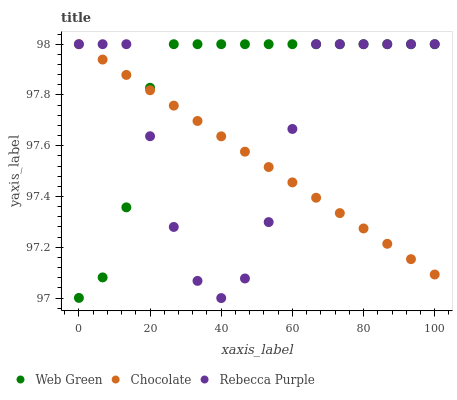Does Chocolate have the minimum area under the curve?
Answer yes or no. Yes. Does Web Green have the maximum area under the curve?
Answer yes or no. Yes. Does Web Green have the minimum area under the curve?
Answer yes or no. No. Does Chocolate have the maximum area under the curve?
Answer yes or no. No. Is Chocolate the smoothest?
Answer yes or no. Yes. Is Rebecca Purple the roughest?
Answer yes or no. Yes. Is Web Green the smoothest?
Answer yes or no. No. Is Web Green the roughest?
Answer yes or no. No. Does Rebecca Purple have the lowest value?
Answer yes or no. Yes. Does Web Green have the lowest value?
Answer yes or no. No. Does Chocolate have the highest value?
Answer yes or no. Yes. Does Chocolate intersect Rebecca Purple?
Answer yes or no. Yes. Is Chocolate less than Rebecca Purple?
Answer yes or no. No. Is Chocolate greater than Rebecca Purple?
Answer yes or no. No. 